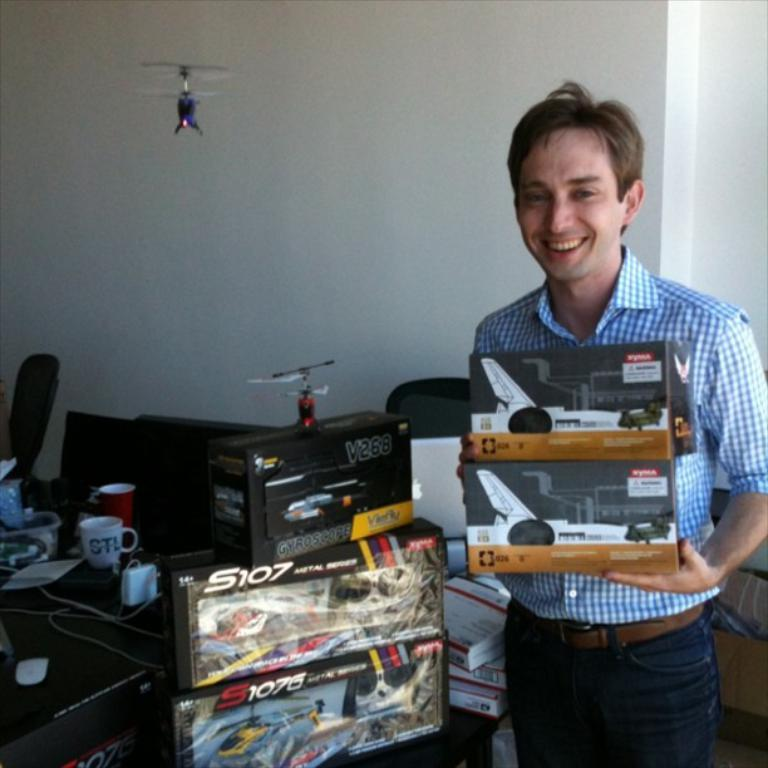Provide a one-sentence caption for the provided image. a person smiles with some boxes of model planes from S107. 